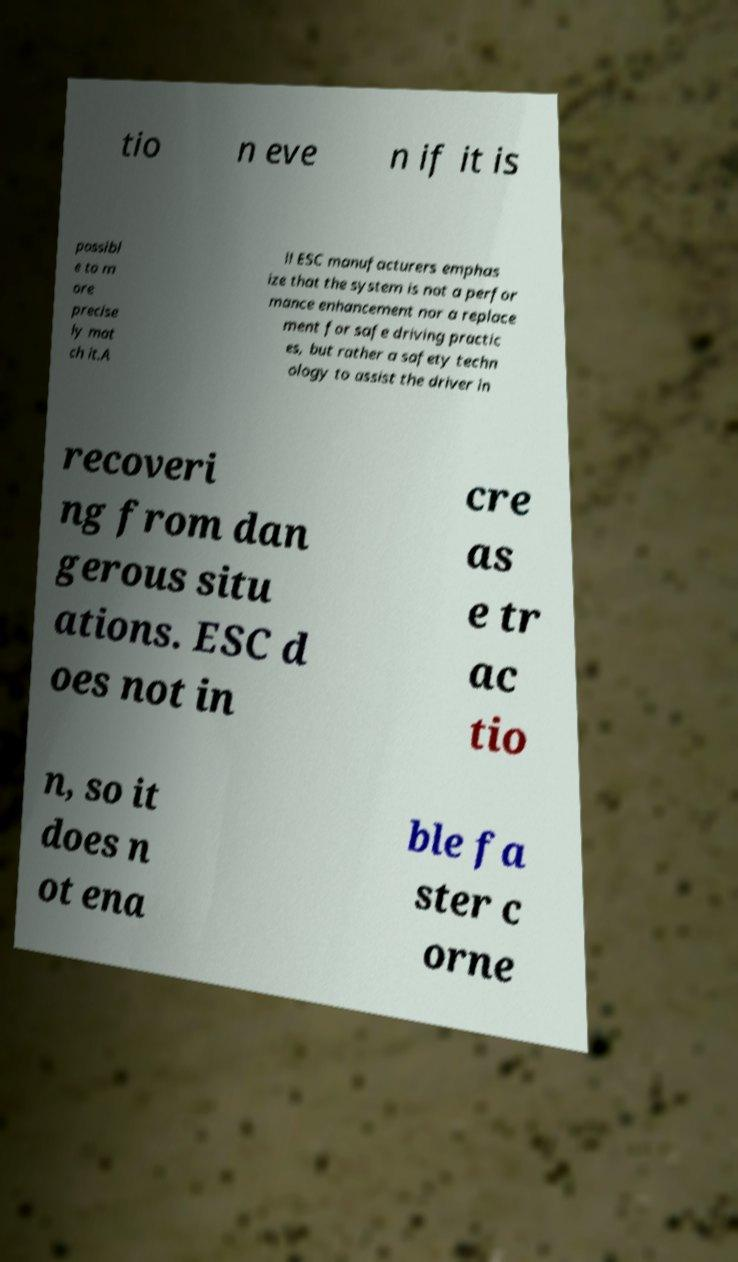Could you extract and type out the text from this image? tio n eve n if it is possibl e to m ore precise ly mat ch it.A ll ESC manufacturers emphas ize that the system is not a perfor mance enhancement nor a replace ment for safe driving practic es, but rather a safety techn ology to assist the driver in recoveri ng from dan gerous situ ations. ESC d oes not in cre as e tr ac tio n, so it does n ot ena ble fa ster c orne 